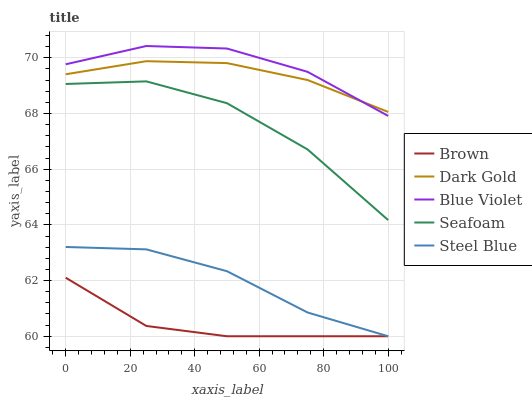Does Brown have the minimum area under the curve?
Answer yes or no. Yes. Does Blue Violet have the maximum area under the curve?
Answer yes or no. Yes. Does Steel Blue have the minimum area under the curve?
Answer yes or no. No. Does Steel Blue have the maximum area under the curve?
Answer yes or no. No. Is Dark Gold the smoothest?
Answer yes or no. Yes. Is Seafoam the roughest?
Answer yes or no. Yes. Is Steel Blue the smoothest?
Answer yes or no. No. Is Steel Blue the roughest?
Answer yes or no. No. Does Brown have the lowest value?
Answer yes or no. Yes. Does Seafoam have the lowest value?
Answer yes or no. No. Does Blue Violet have the highest value?
Answer yes or no. Yes. Does Steel Blue have the highest value?
Answer yes or no. No. Is Seafoam less than Dark Gold?
Answer yes or no. Yes. Is Seafoam greater than Brown?
Answer yes or no. Yes. Does Steel Blue intersect Brown?
Answer yes or no. Yes. Is Steel Blue less than Brown?
Answer yes or no. No. Is Steel Blue greater than Brown?
Answer yes or no. No. Does Seafoam intersect Dark Gold?
Answer yes or no. No. 